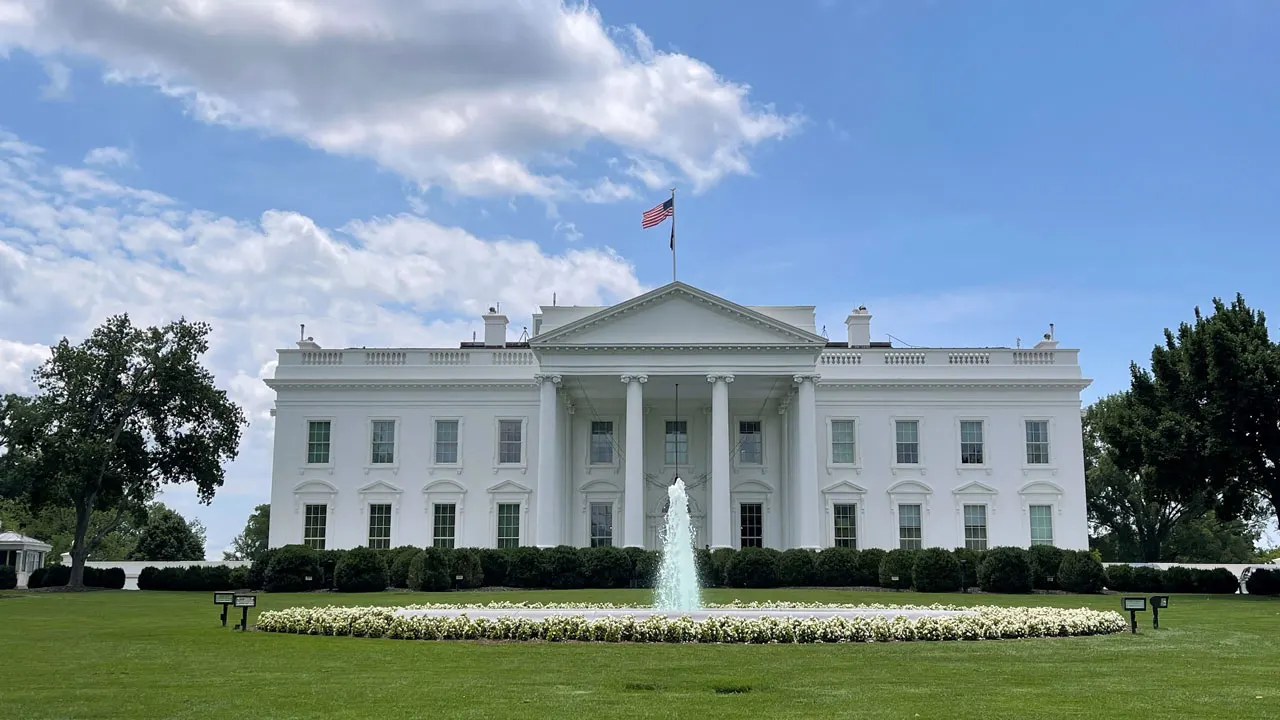Are there any lesser-known features or areas of the White House that aren't visible in this image? Indeed, the White House complex includes several less-visible features, such as the Rose Garden and the South Lawn, which host ceremonial events and gatherings. Beneath the surface lies the Presidential Emergency Operations Center, a secure bunker. There's also the White House kitchen garden, established by First Lady Michelle Obama as part of her initiative to promote healthy eating, which is not shown here. 